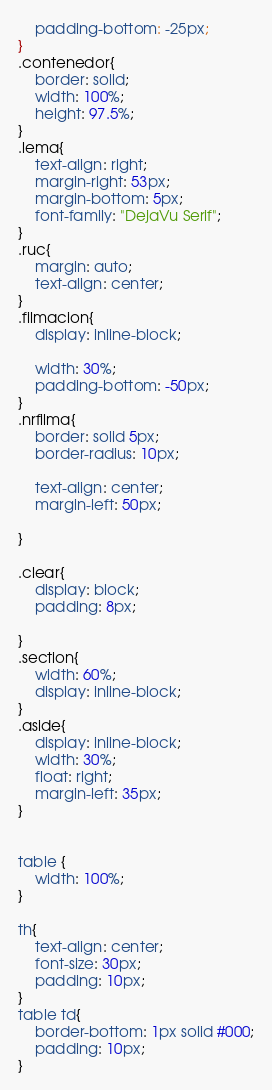Convert code to text. <code><loc_0><loc_0><loc_500><loc_500><_CSS_>    padding-bottom: -25px;
}
.contenedor{
    border: solid;
    width: 100%;
    height: 97.5%;
}
.lema{
    text-align: right;
    margin-right: 53px;
    margin-bottom: 5px;
    font-family: "DejaVu Serif";
}
.ruc{
    margin: auto;
    text-align: center;
}
.filmacion{
    display: inline-block;

    width: 30%;
    padding-bottom: -50px;
}
.nrfilma{
    border: solid 5px;
    border-radius: 10px;

    text-align: center;
    margin-left: 50px;

}

.clear{
    display: block;
    padding: 8px;

}
.section{
    width: 60%;
    display: inline-block;
}
.aside{
    display: inline-block;
    width: 30%;
    float: right;
    margin-left: 35px;
}


table {
    width: 100%;
}

th{
    text-align: center;
    font-size: 30px;
    padding: 10px;
}
table td{
    border-bottom: 1px solid #000;
    padding: 10px;
}





</code> 